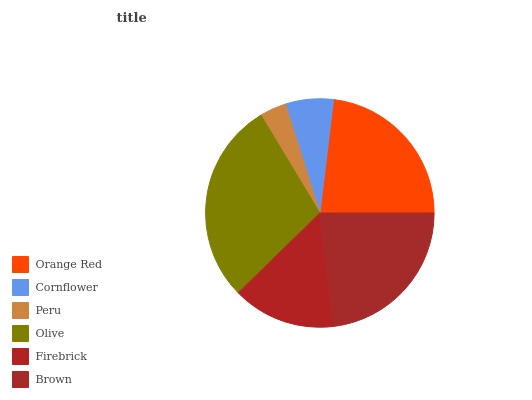Is Peru the minimum?
Answer yes or no. Yes. Is Olive the maximum?
Answer yes or no. Yes. Is Cornflower the minimum?
Answer yes or no. No. Is Cornflower the maximum?
Answer yes or no. No. Is Orange Red greater than Cornflower?
Answer yes or no. Yes. Is Cornflower less than Orange Red?
Answer yes or no. Yes. Is Cornflower greater than Orange Red?
Answer yes or no. No. Is Orange Red less than Cornflower?
Answer yes or no. No. Is Brown the high median?
Answer yes or no. Yes. Is Firebrick the low median?
Answer yes or no. Yes. Is Peru the high median?
Answer yes or no. No. Is Brown the low median?
Answer yes or no. No. 